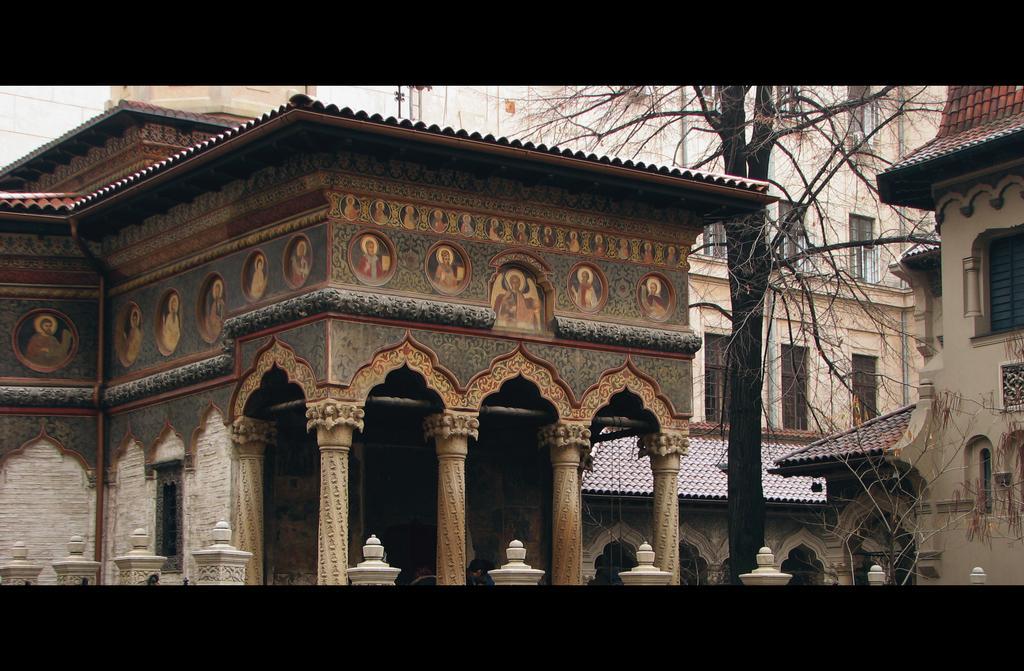Describe this image in one or two sentences. In this image in the center there are buildings, trees and some pillars. And on the left side there is a building, on the building there is some painting. 